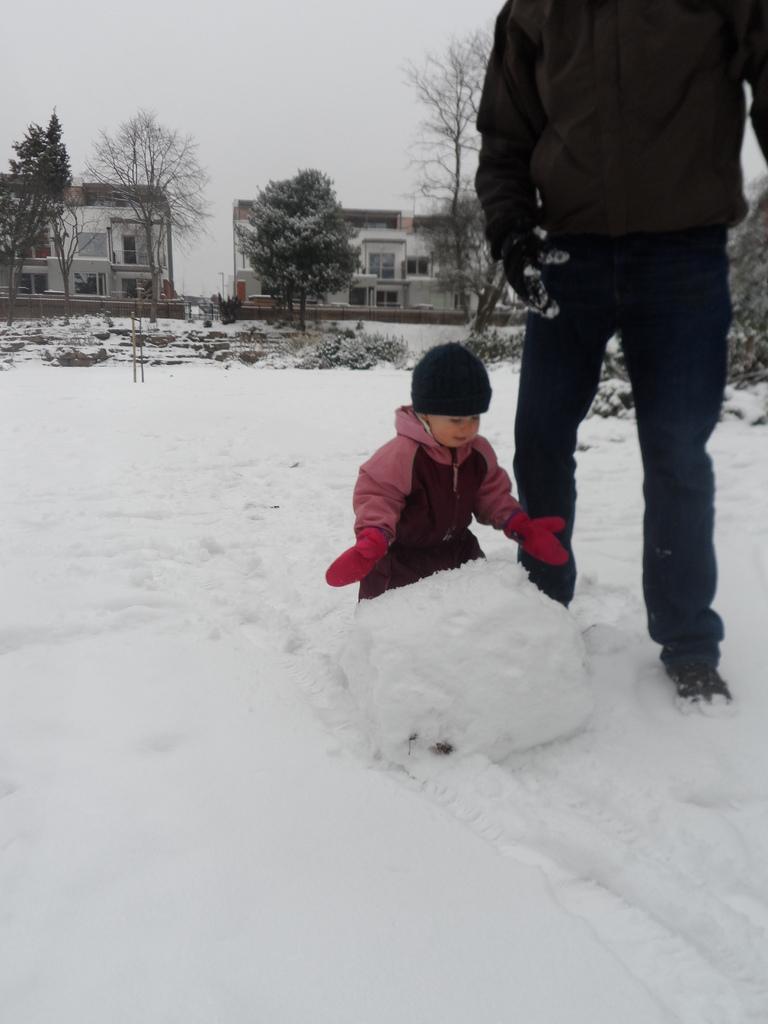Please provide a concise description of this image. In this image we can see there is a person and a child standing on the snow. At the back we can see there are buildings, trees, poles and the sky. 